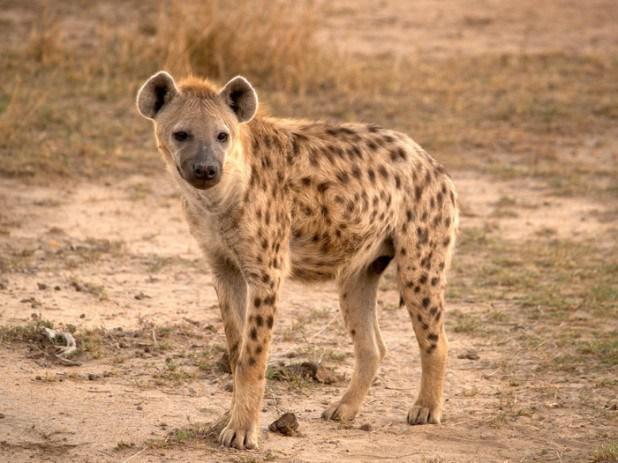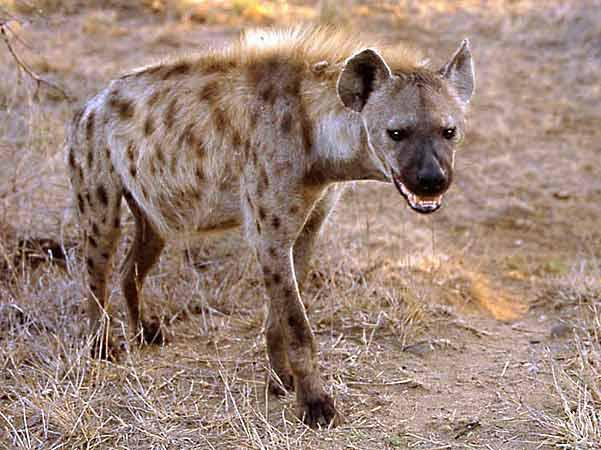The first image is the image on the left, the second image is the image on the right. Evaluate the accuracy of this statement regarding the images: "Two hyenas have their mouths open.". Is it true? Answer yes or no. No. 